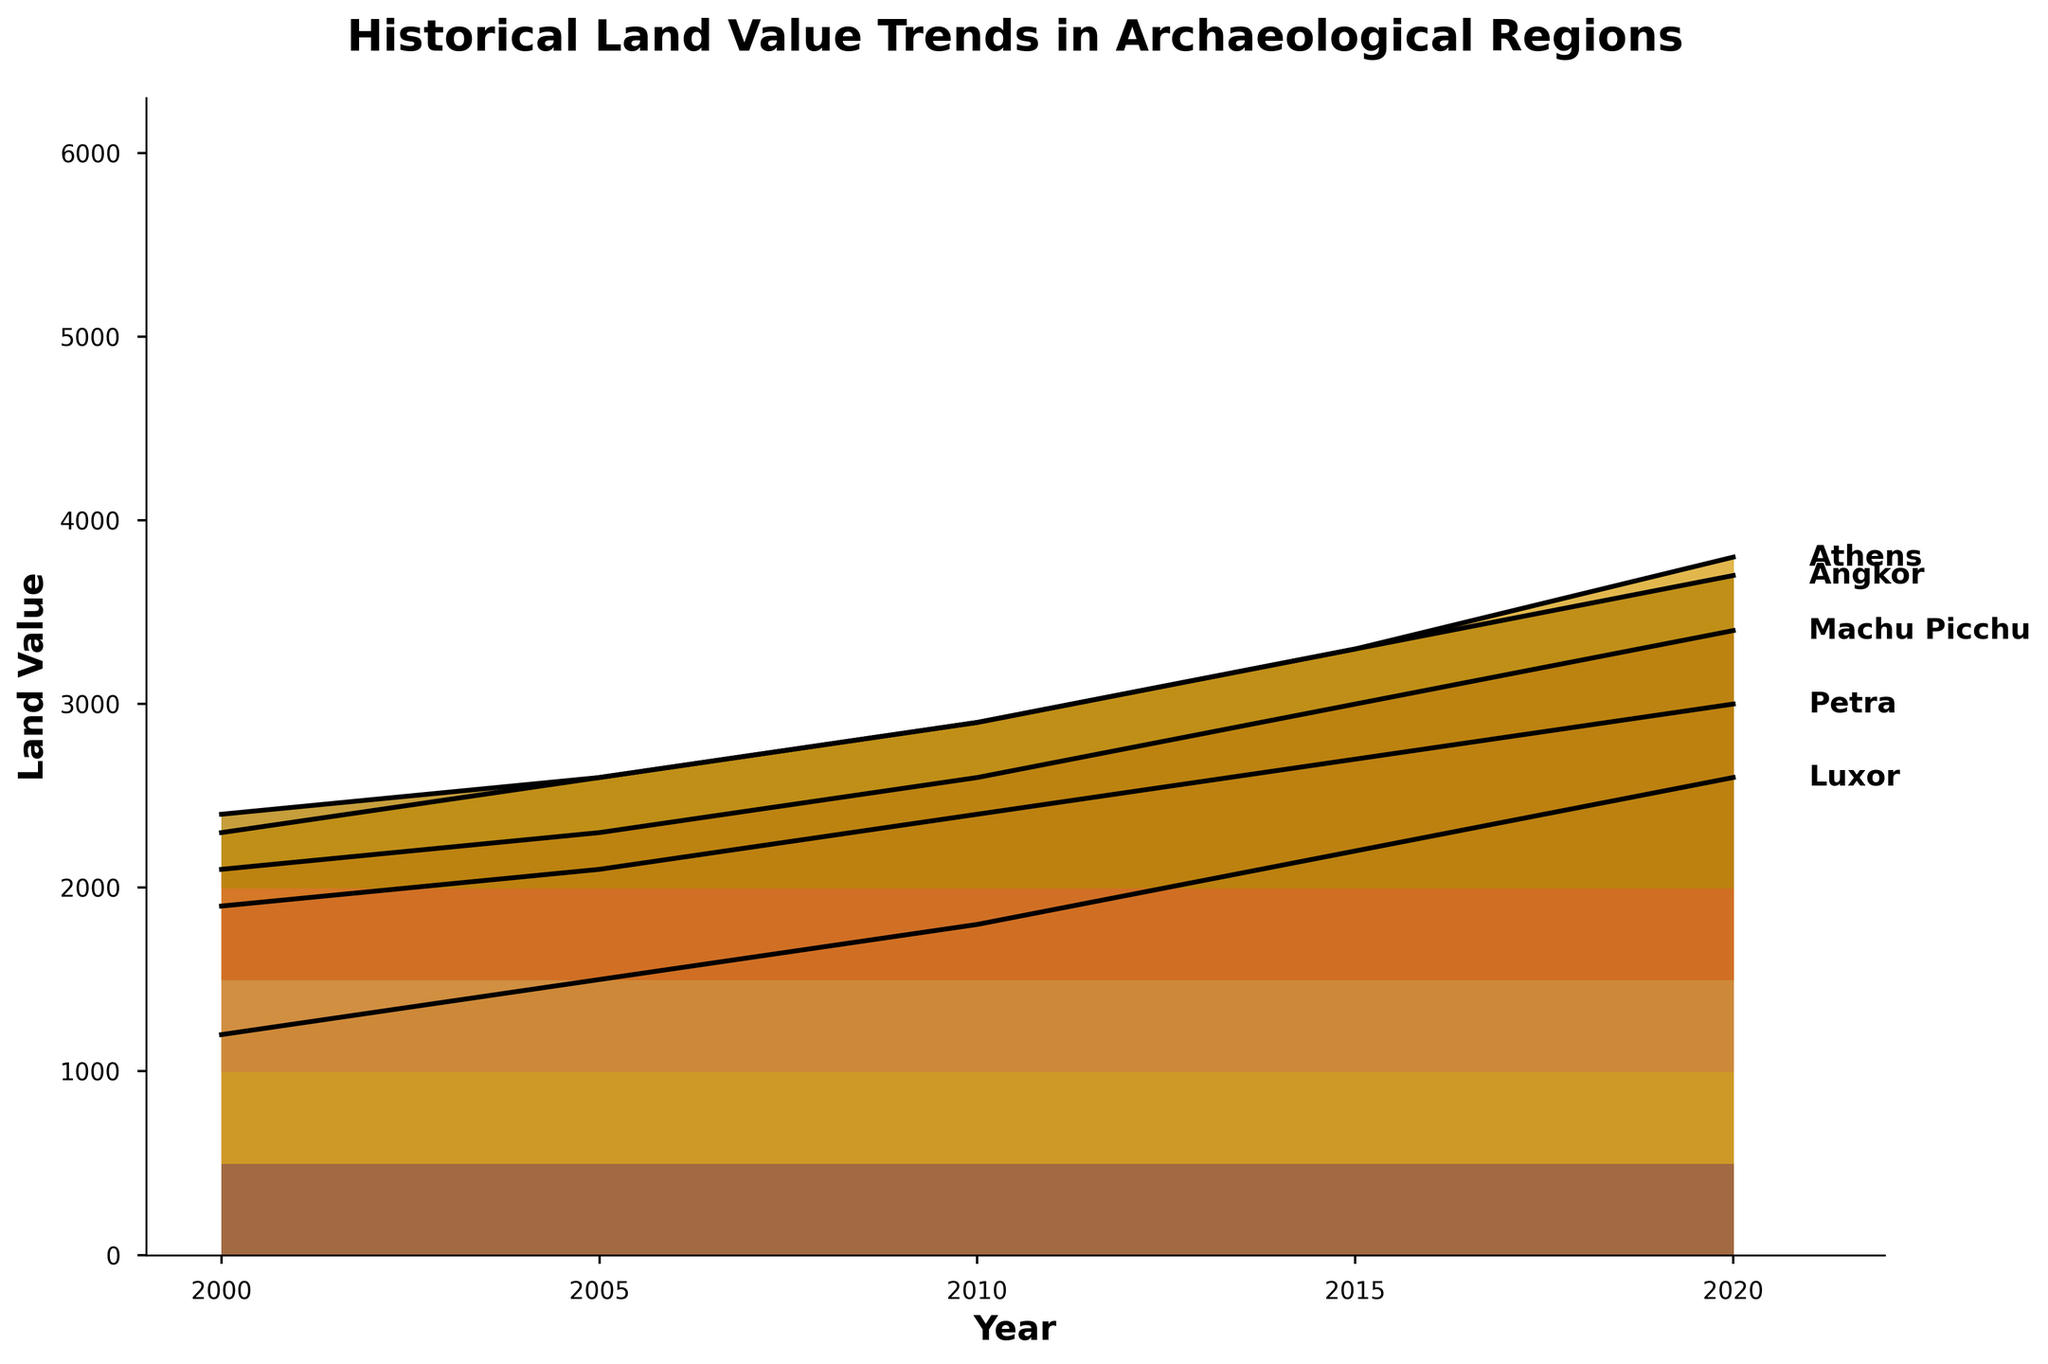What's the title of the plot? The title of the plot is the text at the top of the figure. It reads, 'Historical Land Value Trends in Archaeological Regions'.
Answer: Historical Land Value Trends in Archaeological Regions How many different regions are displayed in the plot? By looking at the different filled areas and labels on the right side of the plot, we can count the total number of unique regions.
Answer: 5 Which region shows the highest land value in 2020? We can identify this by looking at the rightmost side of the plot for the year 2020 and finding the region with the highest peak. According to the plot, Athens has the highest peak in 2020.
Answer: Athens What is the range of years included in the plot? The x-axis of the plot represents the years, and we can see that it ranges from 2000 to 2020.
Answer: 2000-2020 Which region had the lowest land value in 2000, and what was that value? By checking the plot for the year 2000 on the leftmost side and identifying the lowest peak, we see that Angkor had the lowest value, close to 400.
Answer: Angkor, 400 What is the average land value in 2020 across all regions? Look at the values for each region in 2020 and calculate the average: (2600 (Luxor) + 3300 (Athens) + 2000 (Petra) + 1900 (Machu Picchu) + 1700 (Angkor)) / 5 = 11500 / 5 = 2300.
Answer: 2300 Which region has shown the most significant increase in land value from 2000 to 2020? Determine the increase for each region by subtracting the land value in 2000 from that in 2020 and comparing them. The largest difference is Athens (3300 - 1800 = 1500).
Answer: Athens Compare the land value trends of Luxor and Petra between 2000 and 2020. Which region shows a more substantial upward trend? Look at the initial and final values for both regions. Luxor increased from 1200 to 2600 (an increase of 1400), while Petra went from 900 to 2000 (an increase of 1100). Thus, Luxor shows a stronger upward trend.
Answer: Luxor What pattern do you observe in the land value trends of Machu Picchu from 2000 to 2020? Examine the plot's trend for Machu Picchu, from 600 in 2000 steadily increasing each period to 1900 in 2020, indicating a consistent upward trend.
Answer: Consistent upward trend Which two regions have the closest land value in 2010? Locate the values for all regions in 2010: Luxor (1800), Athens (2400), Petra (1400), Machu Picchu (1100), and Angkor (900). The closest values are Petra and Machu Picchu (1400 and 1100), with a difference of 300.
Answer: Petra and Machu Picchu 